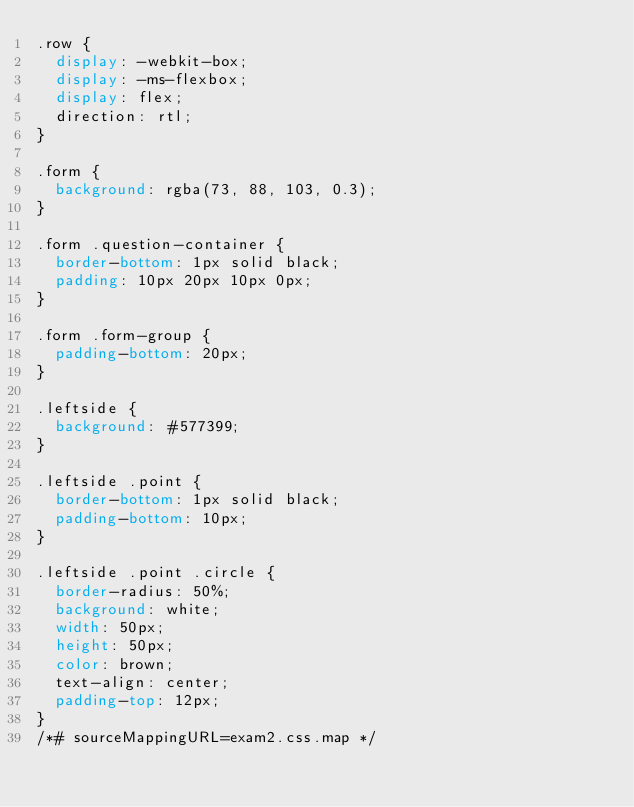<code> <loc_0><loc_0><loc_500><loc_500><_CSS_>.row {
  display: -webkit-box;
  display: -ms-flexbox;
  display: flex;
  direction: rtl;
}

.form {
  background: rgba(73, 88, 103, 0.3);
}

.form .question-container {
  border-bottom: 1px solid black;
  padding: 10px 20px 10px 0px;
}

.form .form-group {
  padding-bottom: 20px;
}

.leftside {
  background: #577399;
}

.leftside .point {
  border-bottom: 1px solid black;
  padding-bottom: 10px;
}

.leftside .point .circle {
  border-radius: 50%;
  background: white;
  width: 50px;
  height: 50px;
  color: brown;
  text-align: center;
  padding-top: 12px;
}
/*# sourceMappingURL=exam2.css.map */</code> 